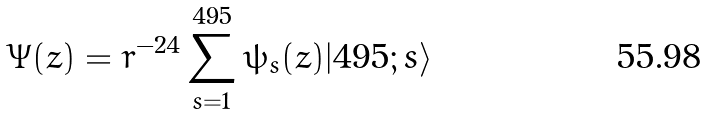Convert formula to latex. <formula><loc_0><loc_0><loc_500><loc_500>\Psi ( z ) = r ^ { - 2 4 } \sum _ { s = 1 } ^ { 4 9 5 } \psi _ { s } ( z ) | 4 9 5 ; s \rangle</formula> 